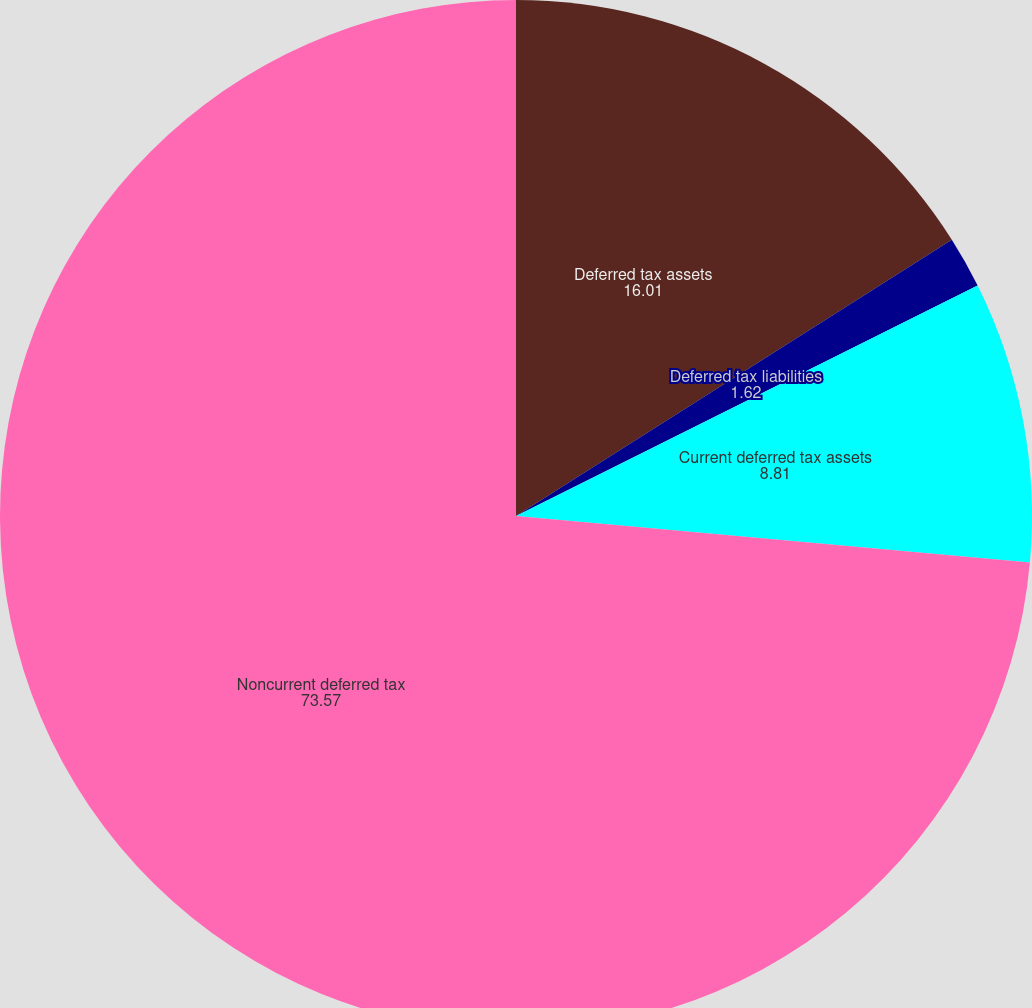Convert chart. <chart><loc_0><loc_0><loc_500><loc_500><pie_chart><fcel>Deferred tax assets<fcel>Deferred tax liabilities<fcel>Current deferred tax assets<fcel>Noncurrent deferred tax<nl><fcel>16.01%<fcel>1.62%<fcel>8.81%<fcel>73.57%<nl></chart> 